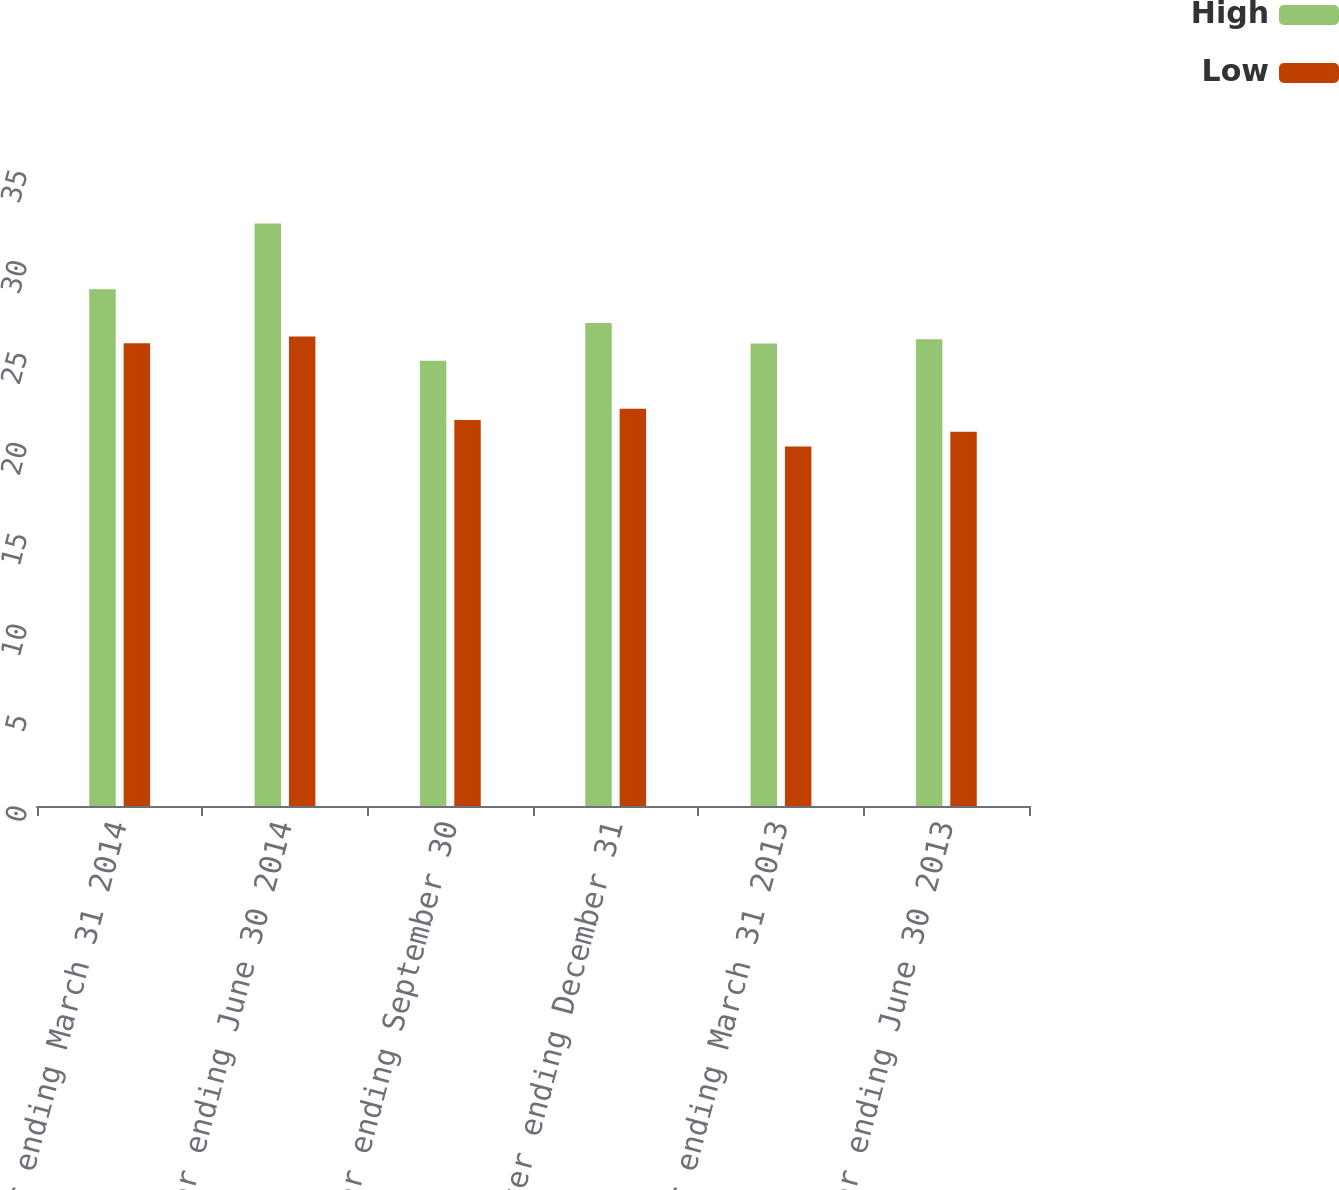Convert chart. <chart><loc_0><loc_0><loc_500><loc_500><stacked_bar_chart><ecel><fcel>Quarter ending March 31 2014<fcel>Quarter ending June 30 2014<fcel>Quarter ending September 30<fcel>Quarter ending December 31<fcel>Quarter ending March 31 2013<fcel>Quarter ending June 30 2013<nl><fcel>High<fcel>28.44<fcel>32.06<fcel>24.5<fcel>26.58<fcel>25.45<fcel>25.69<nl><fcel>Low<fcel>25.47<fcel>25.84<fcel>21.24<fcel>21.86<fcel>19.78<fcel>20.59<nl></chart> 